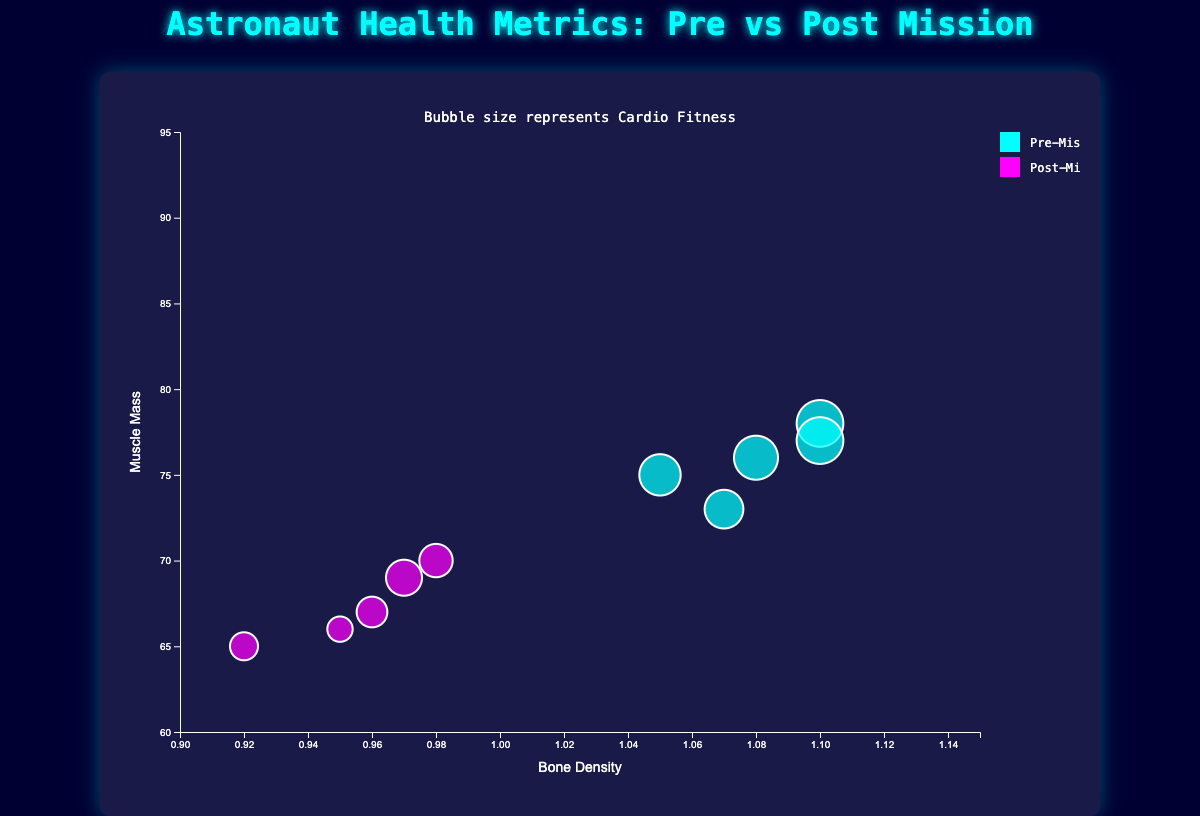What is the title of the figure? The title of the figure is usually displayed at the top of the chart. It summarizes the main topic or focus of the visualized data.
Answer: Astronaut Health Metrics: Pre vs Post Mission What does the color of the bubbles represent? The legend located adjacent to the chart explains the color coding. Blue represents pre-mission health metrics, and magenta represents post-mission health metrics.
Answer: Mission stage (pre and post) How many astronauts' health metrics are shown in the bubble chart? By counting the distinct names or missions related to each set of bubbles in the legend, we find that there are 5 unique astronauts.
Answer: 5 astronauts Which astronaut had the largest decline in muscle mass post-mission? By comparing the y-axis positions of the bubbles before and after the mission for each astronaut, Scott Kelly shows the largest drop from 76 (pre) to 65 (post).
Answer: Scott Kelly Which astronaut maintained the highest cardio fitness level post-mission? By noting the size of the post-mission bubbles, Alexander Gerst shows the largest bubble representing a cardio fitness of 86 post-mission.
Answer: Alexander Gerst What is the average decline in bone density across all astronauts post-mission? Subtract each astronaut's post-mission bone density from their pre-mission bone density, then add these differences together and divide by the number of astronauts: ((1.1-0.98) + (1.05-0.96) + (1.08-0.92) + (1.07-0.95) + (1.1-0.97)) / 5 = 0.114.
Answer: 0.114 Compare the muscle mass of Peggy Whitson pre and post-mission. How much did it change? Peggy Whitson’s pre-mission muscle mass is 75, and her post-mission muscle mass is 67. The difference (75 - 67) = 8.
Answer: 8 units Who had a higher bone density pre-mission, Samantha Cristoforetti or Alexander Gerst? Check the pre-mission bone density values for the two astronauts: Samantha Cristoforetti has 1.07, Alexander Gerst has 1.1. Therefore, Alexander Gerst had a higher bone density.
Answer: Alexander Gerst Which astronaut’s post-mission cardio fitness is closest to their pre-mission cardio fitness? By measuring the size (radius) of the bubbles from the same astronaut in pre and post-mission, Chris Hadfield's post-mission cardio fitness of 85 is the closest to his pre-mission value of 90 with a difference of 5.
Answer: Chris Hadfield 